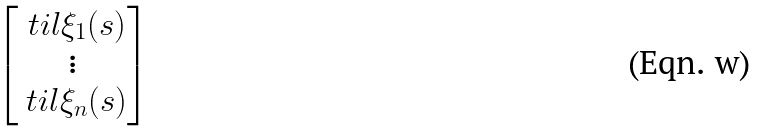<formula> <loc_0><loc_0><loc_500><loc_500>\begin{bmatrix} \ t i l { \xi } _ { 1 } ( s ) \\ \vdots \\ \ t i l { \xi } _ { n } ( s ) \end{bmatrix}</formula> 